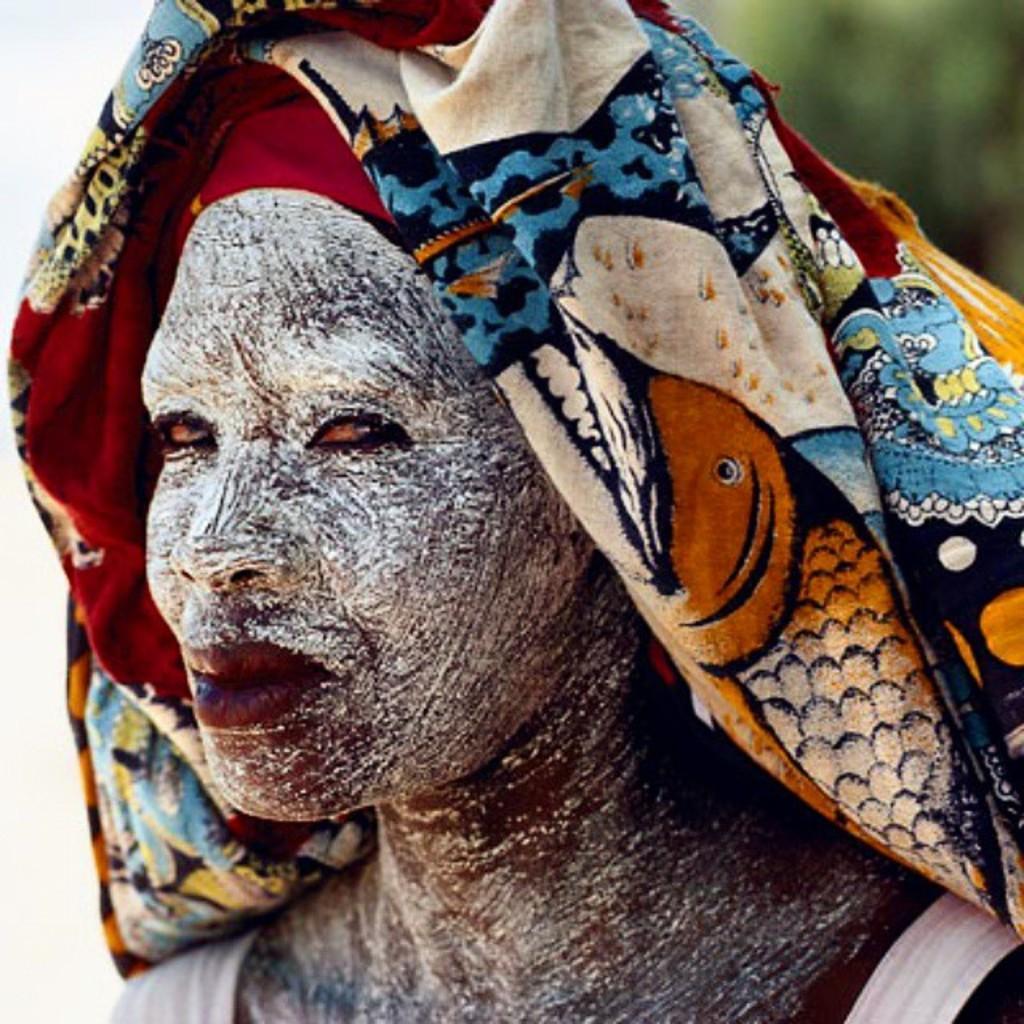Could you give a brief overview of what you see in this image? In this picture there is a person with white dress and there is a white painting on the face and there is a cloth on the head. At the back the image is blurry. 